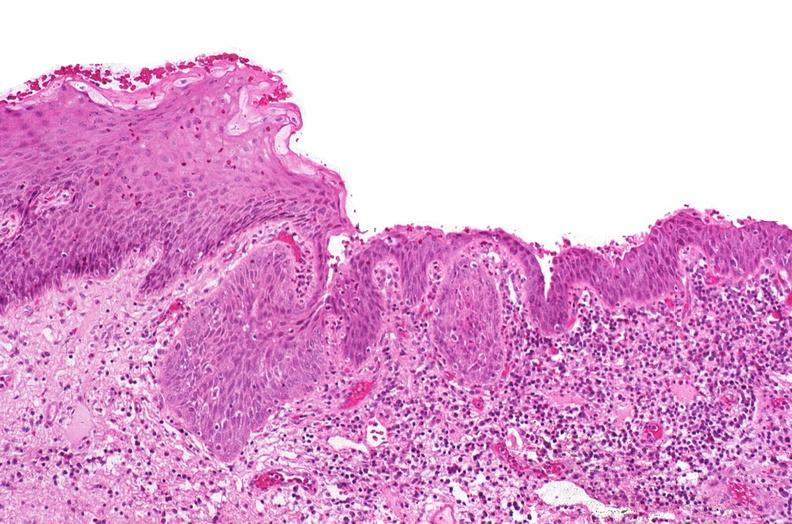what is present?
Answer the question using a single word or phrase. Urinary 